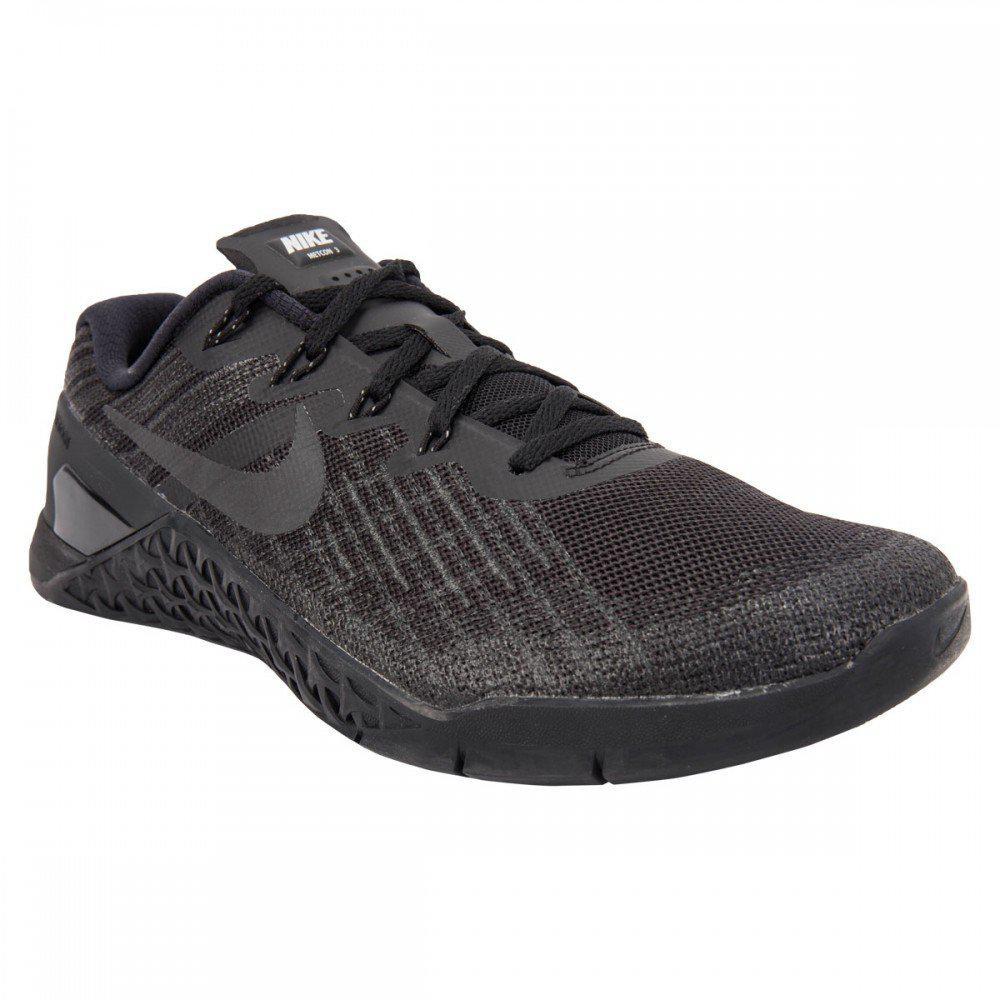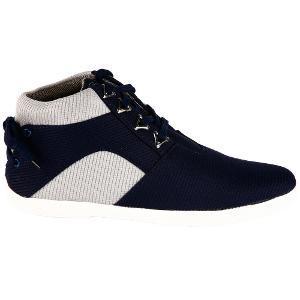The first image is the image on the left, the second image is the image on the right. Assess this claim about the two images: "all visible shoes have the toe side pointing towards the right". Correct or not? Answer yes or no. Yes. The first image is the image on the left, the second image is the image on the right. For the images shown, is this caption "All of the shoes are facing right." true? Answer yes or no. Yes. 